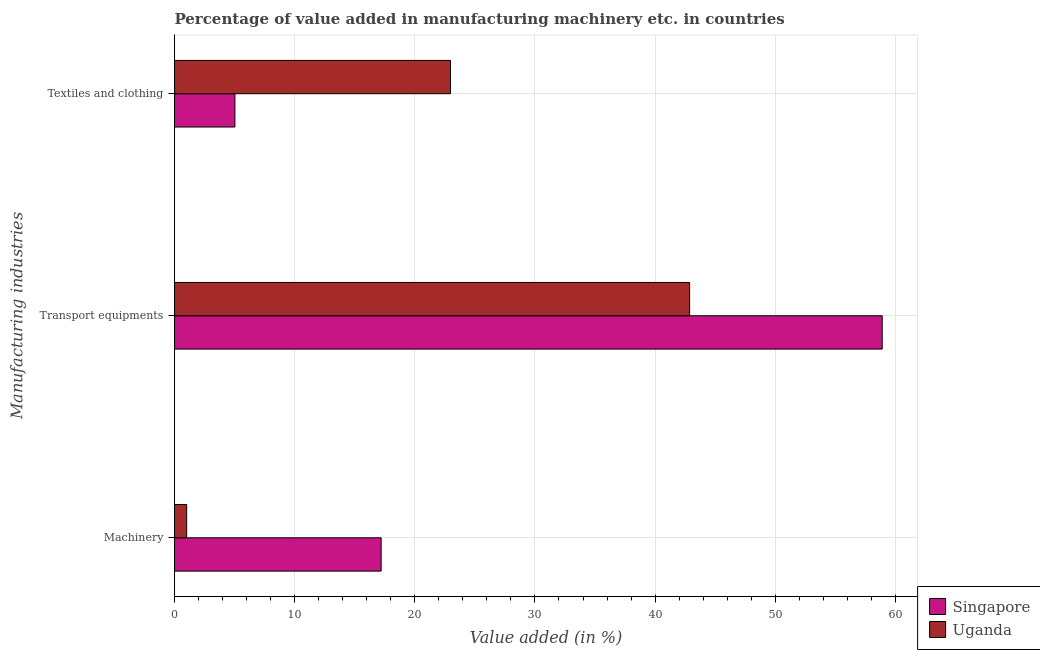How many groups of bars are there?
Give a very brief answer. 3. Are the number of bars per tick equal to the number of legend labels?
Your answer should be very brief. Yes. How many bars are there on the 1st tick from the top?
Give a very brief answer. 2. What is the label of the 2nd group of bars from the top?
Your answer should be compact. Transport equipments. What is the value added in manufacturing transport equipments in Singapore?
Your answer should be very brief. 58.91. Across all countries, what is the maximum value added in manufacturing transport equipments?
Keep it short and to the point. 58.91. Across all countries, what is the minimum value added in manufacturing textile and clothing?
Keep it short and to the point. 5.03. In which country was the value added in manufacturing machinery maximum?
Offer a terse response. Singapore. In which country was the value added in manufacturing machinery minimum?
Ensure brevity in your answer.  Uganda. What is the total value added in manufacturing textile and clothing in the graph?
Provide a short and direct response. 27.99. What is the difference between the value added in manufacturing textile and clothing in Singapore and that in Uganda?
Ensure brevity in your answer.  -17.94. What is the difference between the value added in manufacturing machinery in Singapore and the value added in manufacturing textile and clothing in Uganda?
Your answer should be very brief. -5.77. What is the average value added in manufacturing machinery per country?
Make the answer very short. 9.1. What is the difference between the value added in manufacturing machinery and value added in manufacturing transport equipments in Singapore?
Keep it short and to the point. -41.71. In how many countries, is the value added in manufacturing machinery greater than 38 %?
Offer a very short reply. 0. What is the ratio of the value added in manufacturing textile and clothing in Uganda to that in Singapore?
Offer a terse response. 4.57. Is the value added in manufacturing transport equipments in Singapore less than that in Uganda?
Give a very brief answer. No. What is the difference between the highest and the second highest value added in manufacturing textile and clothing?
Provide a succinct answer. 17.94. What is the difference between the highest and the lowest value added in manufacturing transport equipments?
Provide a succinct answer. 16.03. In how many countries, is the value added in manufacturing textile and clothing greater than the average value added in manufacturing textile and clothing taken over all countries?
Your answer should be compact. 1. What does the 2nd bar from the top in Transport equipments represents?
Make the answer very short. Singapore. What does the 2nd bar from the bottom in Machinery represents?
Offer a very short reply. Uganda. Is it the case that in every country, the sum of the value added in manufacturing machinery and value added in manufacturing transport equipments is greater than the value added in manufacturing textile and clothing?
Your response must be concise. Yes. Are all the bars in the graph horizontal?
Ensure brevity in your answer.  Yes. How many countries are there in the graph?
Your answer should be compact. 2. Are the values on the major ticks of X-axis written in scientific E-notation?
Provide a succinct answer. No. Does the graph contain any zero values?
Your answer should be very brief. No. How are the legend labels stacked?
Ensure brevity in your answer.  Vertical. What is the title of the graph?
Keep it short and to the point. Percentage of value added in manufacturing machinery etc. in countries. What is the label or title of the X-axis?
Offer a very short reply. Value added (in %). What is the label or title of the Y-axis?
Give a very brief answer. Manufacturing industries. What is the Value added (in %) of Singapore in Machinery?
Provide a short and direct response. 17.2. What is the Value added (in %) in Uganda in Machinery?
Keep it short and to the point. 1.01. What is the Value added (in %) in Singapore in Transport equipments?
Your answer should be compact. 58.91. What is the Value added (in %) in Uganda in Transport equipments?
Keep it short and to the point. 42.87. What is the Value added (in %) in Singapore in Textiles and clothing?
Give a very brief answer. 5.03. What is the Value added (in %) in Uganda in Textiles and clothing?
Offer a terse response. 22.97. Across all Manufacturing industries, what is the maximum Value added (in %) of Singapore?
Provide a succinct answer. 58.91. Across all Manufacturing industries, what is the maximum Value added (in %) of Uganda?
Your answer should be compact. 42.87. Across all Manufacturing industries, what is the minimum Value added (in %) in Singapore?
Ensure brevity in your answer.  5.03. Across all Manufacturing industries, what is the minimum Value added (in %) of Uganda?
Offer a terse response. 1.01. What is the total Value added (in %) in Singapore in the graph?
Offer a terse response. 81.13. What is the total Value added (in %) in Uganda in the graph?
Ensure brevity in your answer.  66.85. What is the difference between the Value added (in %) in Singapore in Machinery and that in Transport equipments?
Provide a succinct answer. -41.71. What is the difference between the Value added (in %) of Uganda in Machinery and that in Transport equipments?
Provide a short and direct response. -41.87. What is the difference between the Value added (in %) of Singapore in Machinery and that in Textiles and clothing?
Ensure brevity in your answer.  12.17. What is the difference between the Value added (in %) of Uganda in Machinery and that in Textiles and clothing?
Provide a short and direct response. -21.96. What is the difference between the Value added (in %) in Singapore in Transport equipments and that in Textiles and clothing?
Provide a short and direct response. 53.88. What is the difference between the Value added (in %) of Uganda in Transport equipments and that in Textiles and clothing?
Offer a very short reply. 19.9. What is the difference between the Value added (in %) in Singapore in Machinery and the Value added (in %) in Uganda in Transport equipments?
Provide a short and direct response. -25.68. What is the difference between the Value added (in %) in Singapore in Machinery and the Value added (in %) in Uganda in Textiles and clothing?
Offer a terse response. -5.77. What is the difference between the Value added (in %) of Singapore in Transport equipments and the Value added (in %) of Uganda in Textiles and clothing?
Your answer should be very brief. 35.94. What is the average Value added (in %) in Singapore per Manufacturing industries?
Provide a succinct answer. 27.04. What is the average Value added (in %) of Uganda per Manufacturing industries?
Keep it short and to the point. 22.28. What is the difference between the Value added (in %) in Singapore and Value added (in %) in Uganda in Machinery?
Ensure brevity in your answer.  16.19. What is the difference between the Value added (in %) of Singapore and Value added (in %) of Uganda in Transport equipments?
Offer a very short reply. 16.03. What is the difference between the Value added (in %) in Singapore and Value added (in %) in Uganda in Textiles and clothing?
Keep it short and to the point. -17.94. What is the ratio of the Value added (in %) of Singapore in Machinery to that in Transport equipments?
Your answer should be very brief. 0.29. What is the ratio of the Value added (in %) in Uganda in Machinery to that in Transport equipments?
Ensure brevity in your answer.  0.02. What is the ratio of the Value added (in %) of Singapore in Machinery to that in Textiles and clothing?
Your answer should be very brief. 3.42. What is the ratio of the Value added (in %) in Uganda in Machinery to that in Textiles and clothing?
Offer a very short reply. 0.04. What is the ratio of the Value added (in %) of Singapore in Transport equipments to that in Textiles and clothing?
Keep it short and to the point. 11.72. What is the ratio of the Value added (in %) in Uganda in Transport equipments to that in Textiles and clothing?
Give a very brief answer. 1.87. What is the difference between the highest and the second highest Value added (in %) in Singapore?
Provide a succinct answer. 41.71. What is the difference between the highest and the second highest Value added (in %) in Uganda?
Give a very brief answer. 19.9. What is the difference between the highest and the lowest Value added (in %) in Singapore?
Offer a terse response. 53.88. What is the difference between the highest and the lowest Value added (in %) of Uganda?
Offer a very short reply. 41.87. 